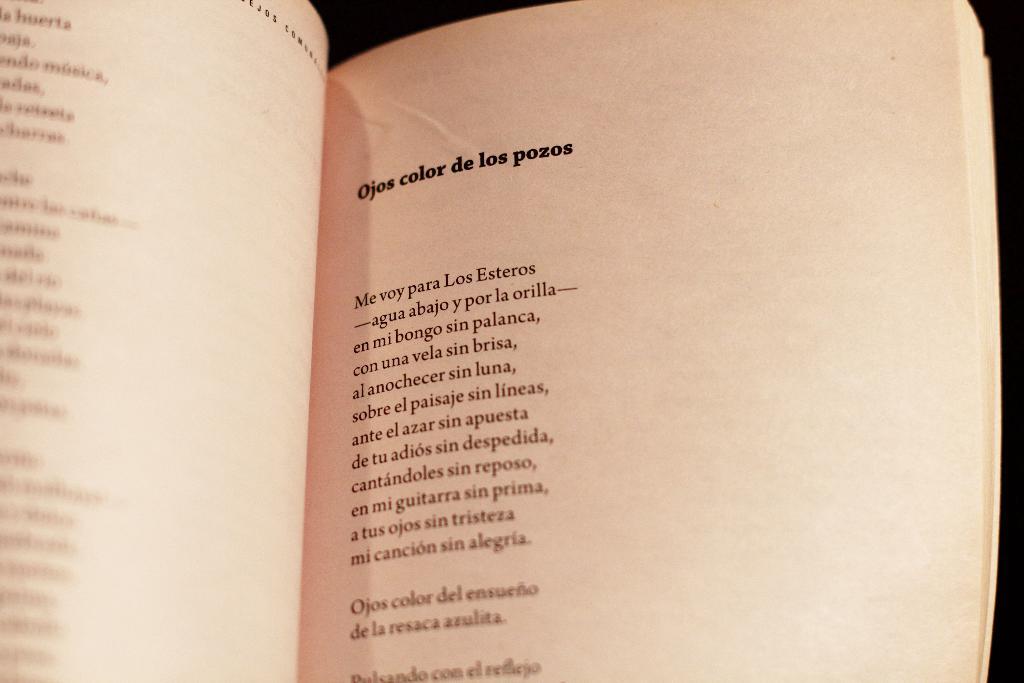What is the second word in the title?
Offer a terse response. Color. This a book?
Provide a short and direct response. Yes. 